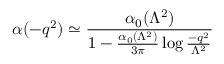<formula> <loc_0><loc_0><loc_500><loc_500>\alpha ( - q ^ { 2 } ) \simeq { \frac { \alpha _ { 0 } ( \Lambda ^ { 2 } ) } { 1 - { \frac { \alpha _ { 0 } ( \Lambda ^ { 2 } ) } { 3 \pi } } \log { \frac { - q ^ { 2 } } { \Lambda ^ { 2 } } } } }</formula> 